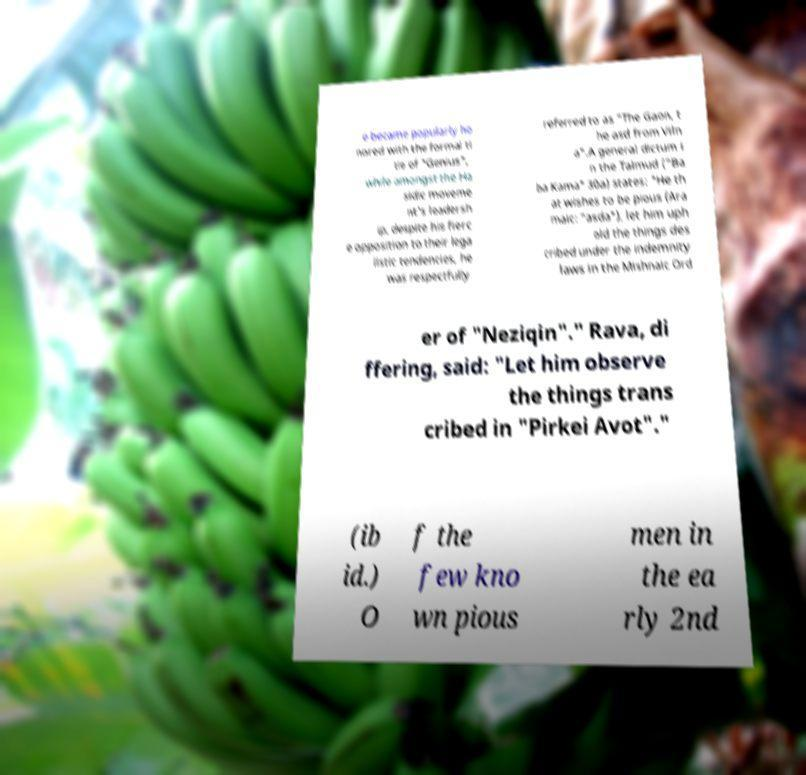There's text embedded in this image that I need extracted. Can you transcribe it verbatim? e became popularly ho nored with the formal ti tle of "Genius", while amongst the Ha sidic moveme nt's leadersh ip, despite his fierc e opposition to their lega listic tendencies, he was respectfully referred to as "The Gaon, t he asd from Viln a".A general dictum i n the Talmud ("Ba ba Kama" 30a) states: "He th at wishes to be pious (Ara maic: "asda"), let him uph old the things des cribed under the indemnity laws in the Mishnaic Ord er of "Neziqin"." Rava, di ffering, said: "Let him observe the things trans cribed in "Pirkei Avot"." (ib id.) O f the few kno wn pious men in the ea rly 2nd 